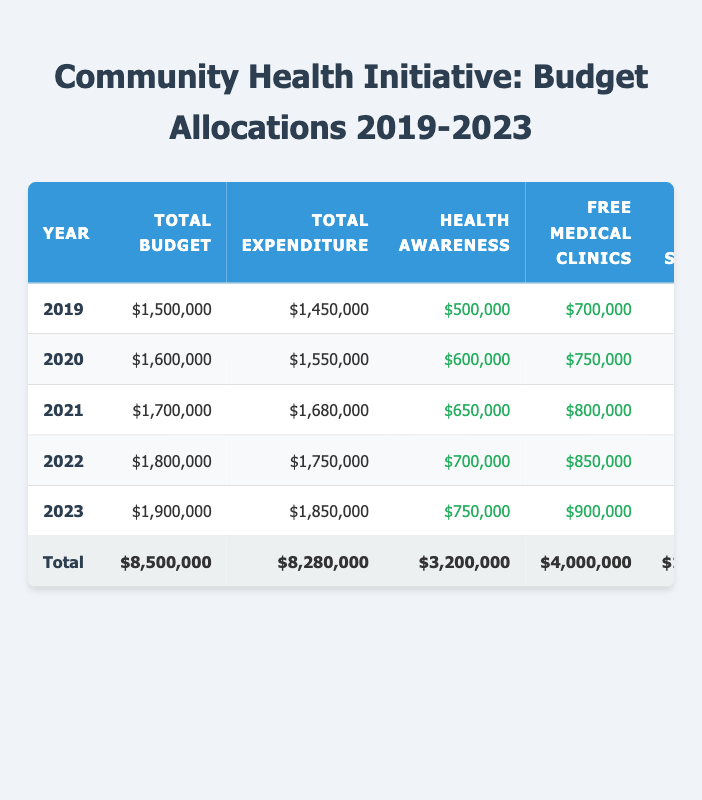What was the total budget allocation for the year 2021? Looking at the table, the row for the year 2021 shows the Total Budget Allocation as $1,700,000.
Answer: $1,700,000 What were the total expenditures for the year 2020? In the row for 2020, the Total Expenditure is listed as $1,550,000.
Answer: $1,550,000 Which program received the highest funding in 2023? By reviewing the 2023 row, the Free Medical Clinics received $900,000, which is the highest among the program funding amounts.
Answer: Free Medical Clinics In how many years was the total expenditure less than the total budget allocation? Analyzing all years in the table, total expenditures were less than total budget allocations in 2019, 2020, 2021, 2022, and 2023.
Answer: 5 years What is the total funding allocated to Mental Health Services over the five years? Adding the funding from the Mental Health Services column: $200,000 (2019) + $250,000 (2020) + $300,000 (2021) + $350,000 (2022) + $400,000 (2023) equals $1,500,000.
Answer: $1,500,000 Was the total expenditure for 2022 lower than the total expenditure for 2021? The total expenditure for 2022 is $1,750,000, while for 2021 it is $1,680,000. Since $1,750,000 is greater than $1,680,000, this statement is false.
Answer: No What was the average administrative cost across the five years? The administrative costs for each year are constant at $200,000. Therefore, the average is simply $200,000.
Answer: $200,000 What is the total budget allocation for all years combined? Summing the Total Budget Allocations: $1,500,000 + $1,600,000 + $1,700,000 + $1,800,000 + $1,900,000 = $8,500,000.
Answer: $8,500,000 Did the funding for the Health Awareness Campaign increase every year? Checking the yearly funding amounts for the Health Awareness Campaign shows: $500,000 (2019), $600,000 (2020), $650,000 (2021), $700,000 (2022), $750,000 (2023), indicating a consistent increase each year.
Answer: Yes Calculate the percentage increase in total budget allocation from 2019 to 2023. The total budget in 2019 was $1,500,000 and in 2023 it is $1,900,000. The increase is $1,900,000 - $1,500,000 = $400,000. To find the percentage increase, use the formula: (Increase / Original) x 100, which is ($400,000 / $1,500,000) x 100 = 26.67%.
Answer: 26.67% 